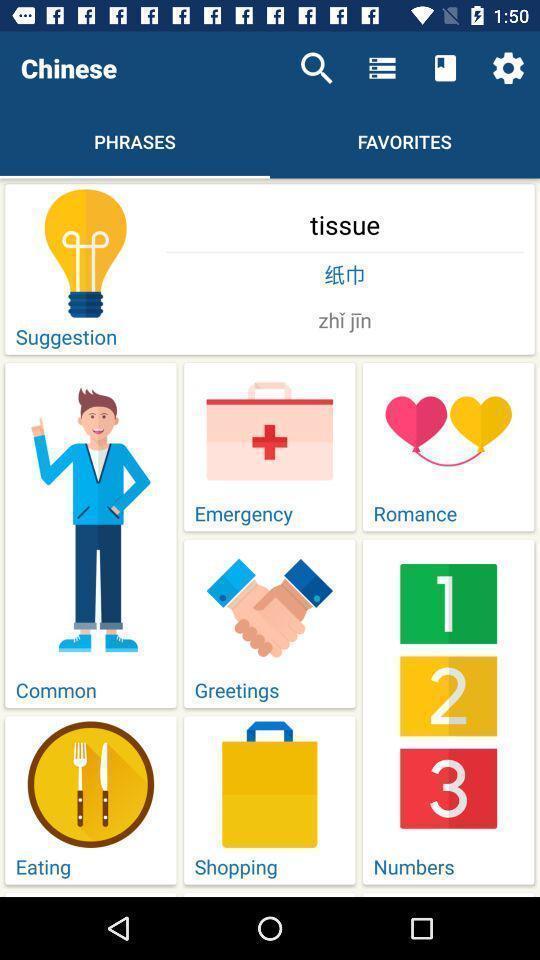Provide a description of this screenshot. Window displaying a learning app. 